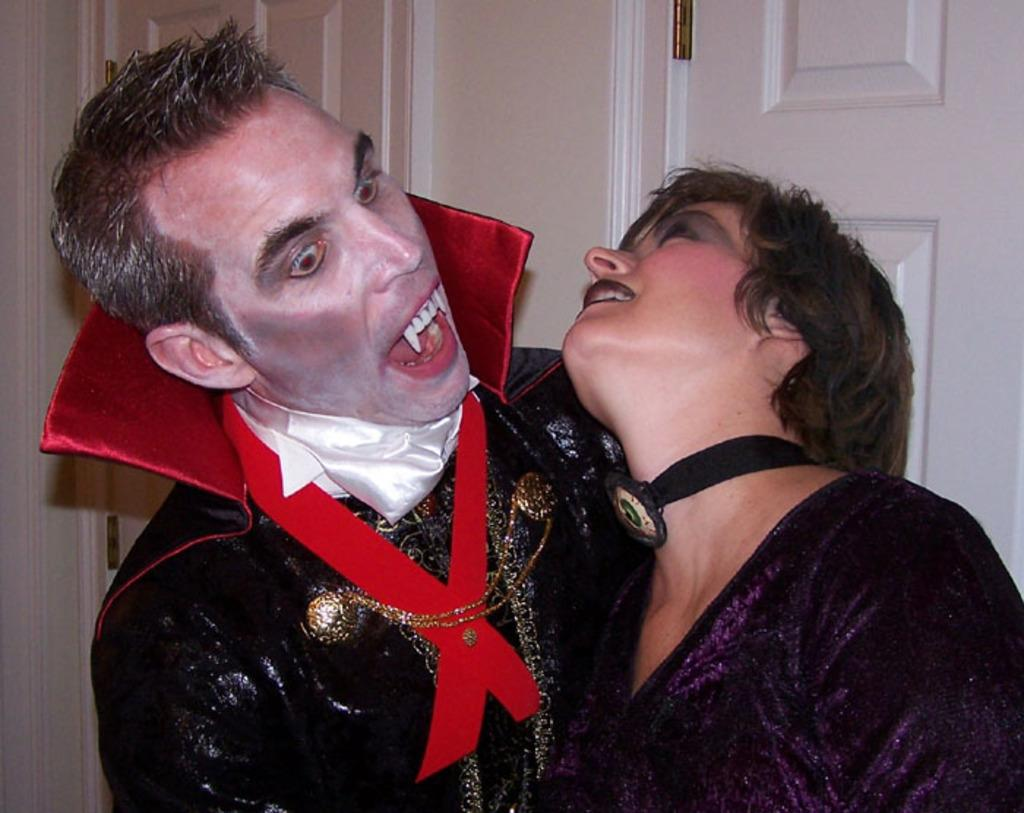What can be seen in the foreground of the image? There are people with costumes in the foreground of the image. What is visible in the background of the image? There are doors and a wall in the background of the image. What is the aftermath of the train crash in the image? There is no train crash or train present in the image; it features people with costumes in the foreground and doors and a wall in the background. 